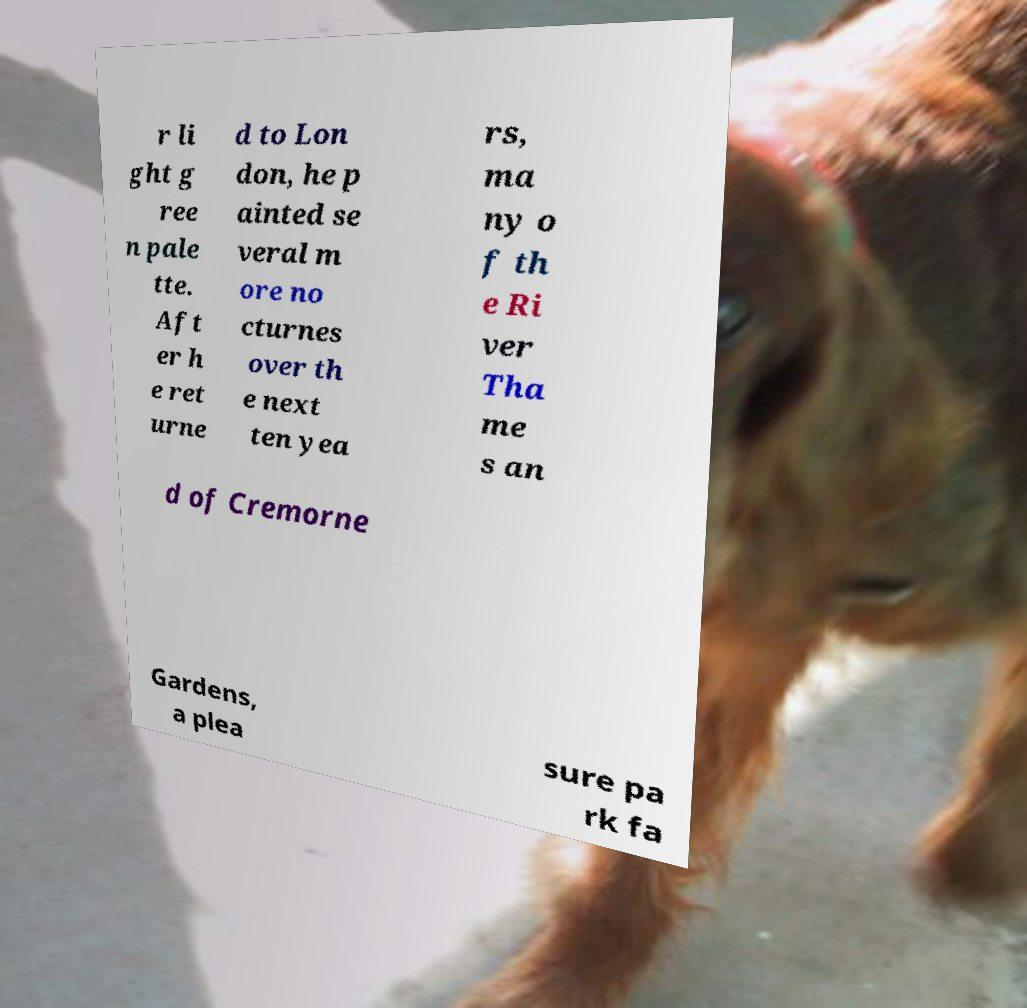Can you accurately transcribe the text from the provided image for me? r li ght g ree n pale tte. Aft er h e ret urne d to Lon don, he p ainted se veral m ore no cturnes over th e next ten yea rs, ma ny o f th e Ri ver Tha me s an d of Cremorne Gardens, a plea sure pa rk fa 